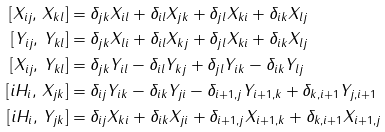Convert formula to latex. <formula><loc_0><loc_0><loc_500><loc_500>[ X _ { i j } , \, X _ { k l } ] & = \delta _ { j k } X _ { i l } + \delta _ { i l } X _ { j k } + \delta _ { j l } X _ { k i } + \delta _ { i k } X _ { l j } \\ [ Y _ { i j } , \, Y _ { k l } ] & = \delta _ { j k } X _ { l i } + \delta _ { i l } X _ { k j } + \delta _ { j l } X _ { k i } + \delta _ { i k } X _ { l j } \\ [ X _ { i j } , \, Y _ { k l } ] & = \delta _ { j k } Y _ { i l } - \delta _ { i l } Y _ { k j } + \delta _ { j l } Y _ { i k } - \delta _ { i k } Y _ { l j } \\ [ i H _ { i } , \, X _ { j k } ] & = \delta _ { i j } Y _ { i k } - \delta _ { i k } Y _ { j i } - \delta _ { i + 1 , j } Y _ { i + 1 , k } + \delta _ { k , i + 1 } Y _ { j , i + 1 } \\ [ i H _ { i } , \, Y _ { j k } ] & = \delta _ { i j } X _ { k i } + \delta _ { i k } X _ { j i } + \delta _ { i + 1 , j } X _ { i + 1 , k } + \delta _ { k , i + 1 } X _ { i + 1 , j }</formula> 